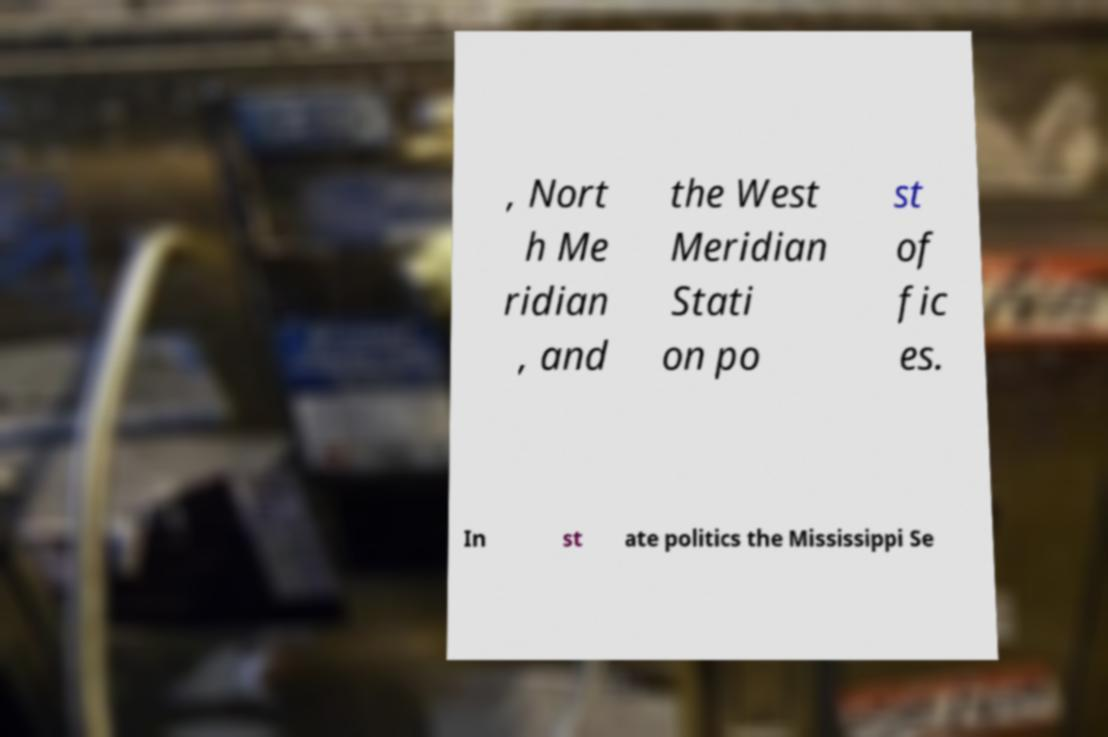What messages or text are displayed in this image? I need them in a readable, typed format. , Nort h Me ridian , and the West Meridian Stati on po st of fic es. In st ate politics the Mississippi Se 